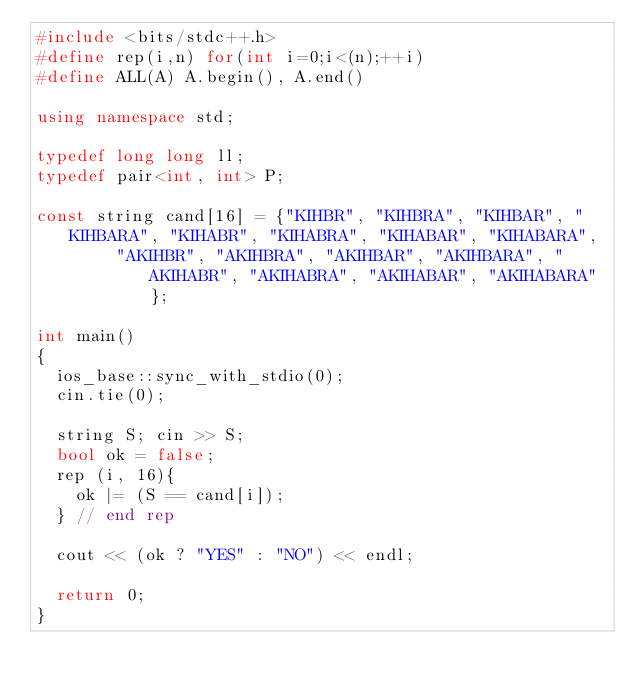Convert code to text. <code><loc_0><loc_0><loc_500><loc_500><_C++_>#include <bits/stdc++.h>
#define rep(i,n) for(int i=0;i<(n);++i)
#define ALL(A) A.begin(), A.end()

using namespace std;

typedef long long ll;
typedef pair<int, int> P;

const string cand[16] = {"KIHBR", "KIHBRA", "KIHBAR", "KIHBARA", "KIHABR", "KIHABRA", "KIHABAR", "KIHABARA",
				"AKIHBR", "AKIHBRA", "AKIHBAR", "AKIHBARA", "AKIHABR", "AKIHABRA", "AKIHABAR", "AKIHABARA"};

int main()
{
	ios_base::sync_with_stdio(0);
	cin.tie(0);

	string S; cin >> S;
	bool ok = false;
	rep (i, 16){
		ok |= (S == cand[i]);
	} // end rep

	cout << (ok ? "YES" : "NO") << endl;

	return 0;
}</code> 